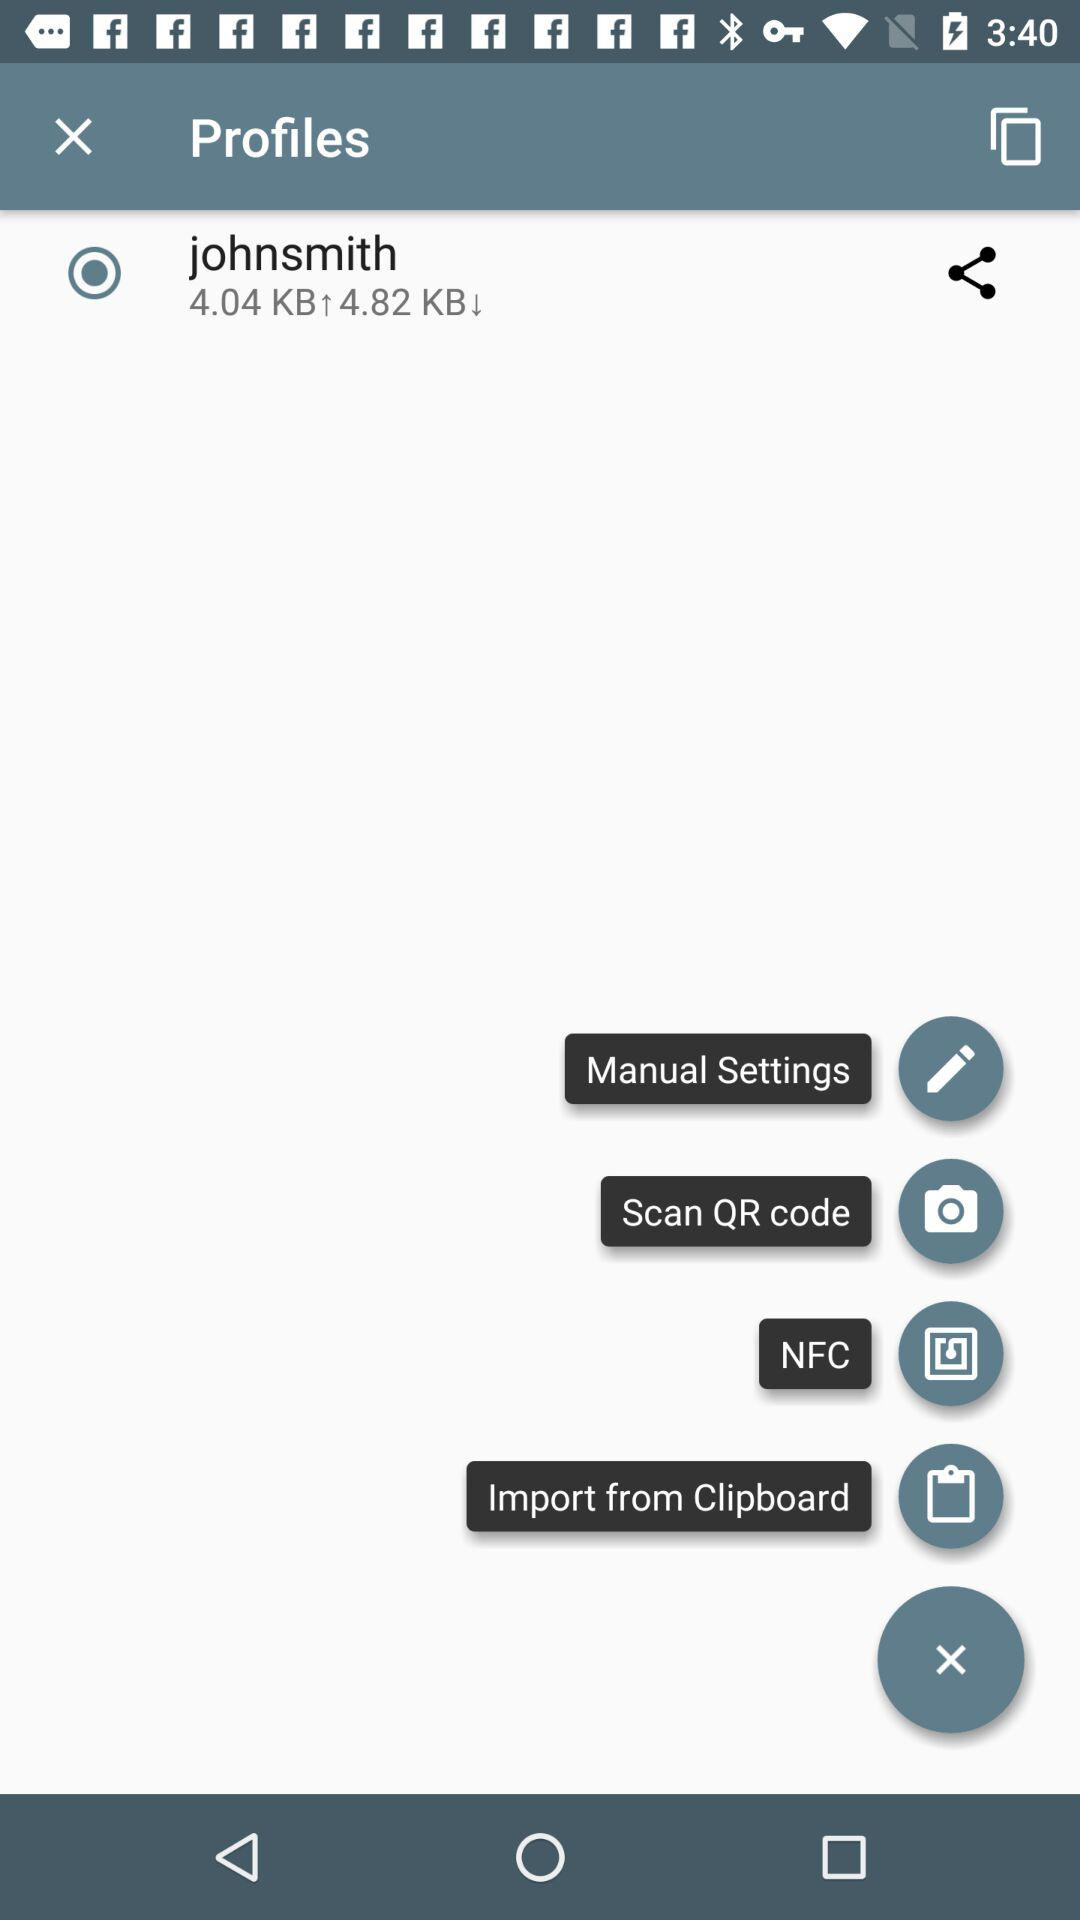How much is upload speed? The upload speed is 4.04 KB. 